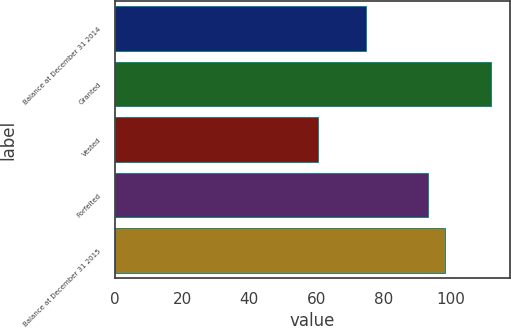Convert chart. <chart><loc_0><loc_0><loc_500><loc_500><bar_chart><fcel>Balance at December 31 2014<fcel>Granted<fcel>Vested<fcel>Forfeited<fcel>Balance at December 31 2015<nl><fcel>74.83<fcel>112.02<fcel>60.5<fcel>93.2<fcel>98.35<nl></chart> 